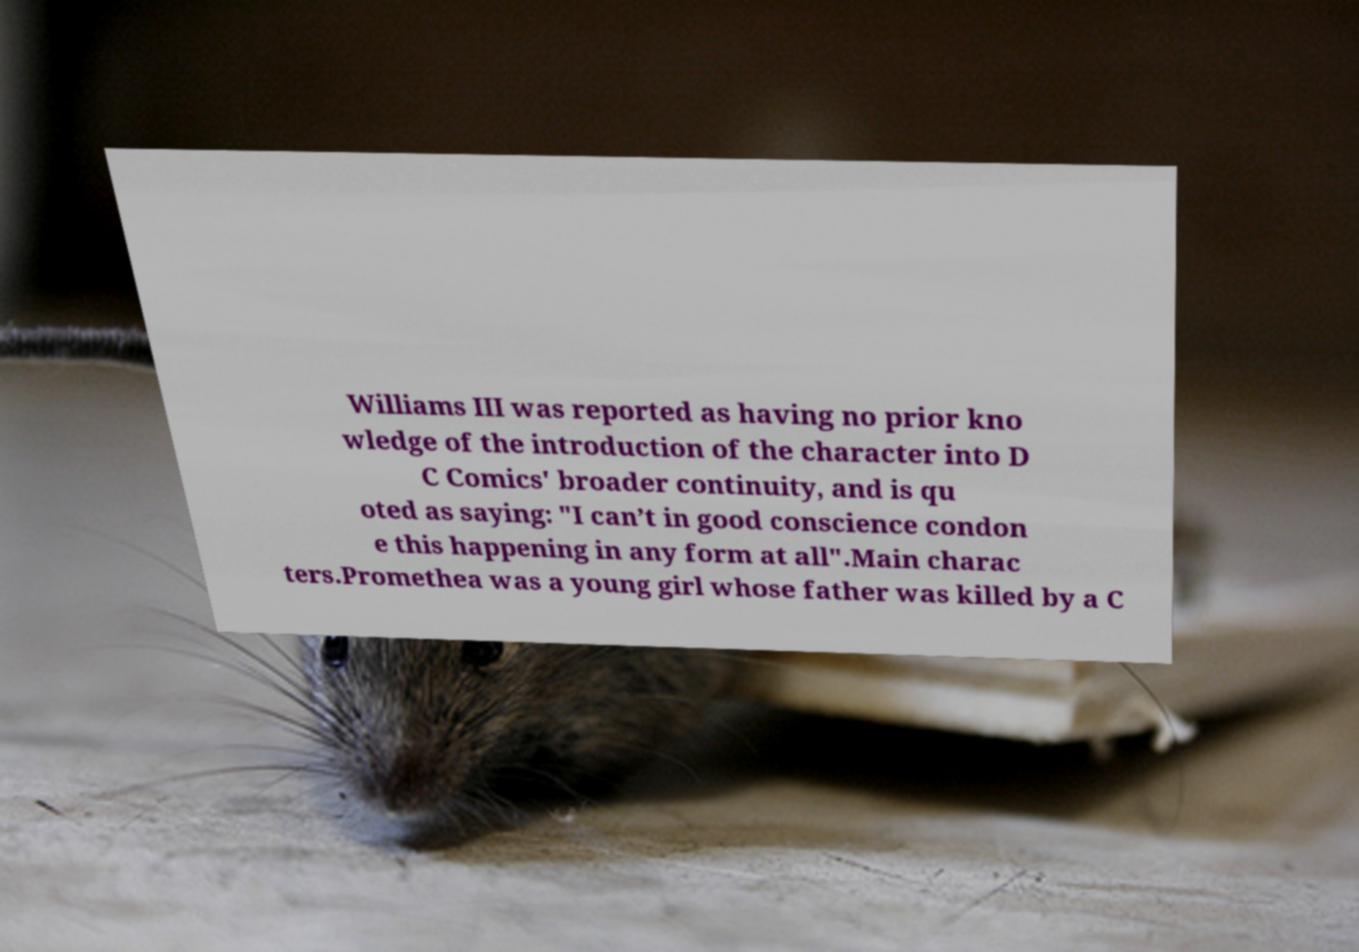I need the written content from this picture converted into text. Can you do that? Williams III was reported as having no prior kno wledge of the introduction of the character into D C Comics' broader continuity, and is qu oted as saying: "I can’t in good conscience condon e this happening in any form at all".Main charac ters.Promethea was a young girl whose father was killed by a C 